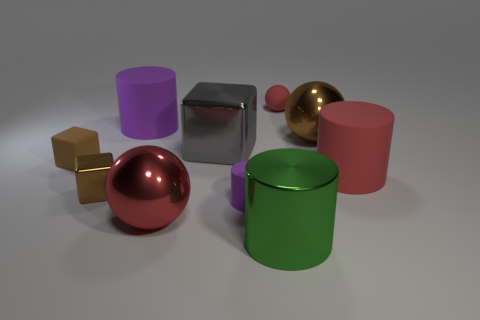Subtract 1 cylinders. How many cylinders are left? 3 Subtract all green spheres. Subtract all brown cylinders. How many spheres are left? 3 Subtract all balls. How many objects are left? 7 Subtract 0 purple blocks. How many objects are left? 10 Subtract all small cyan matte objects. Subtract all large green metal cylinders. How many objects are left? 9 Add 1 large brown things. How many large brown things are left? 2 Add 3 large purple cylinders. How many large purple cylinders exist? 4 